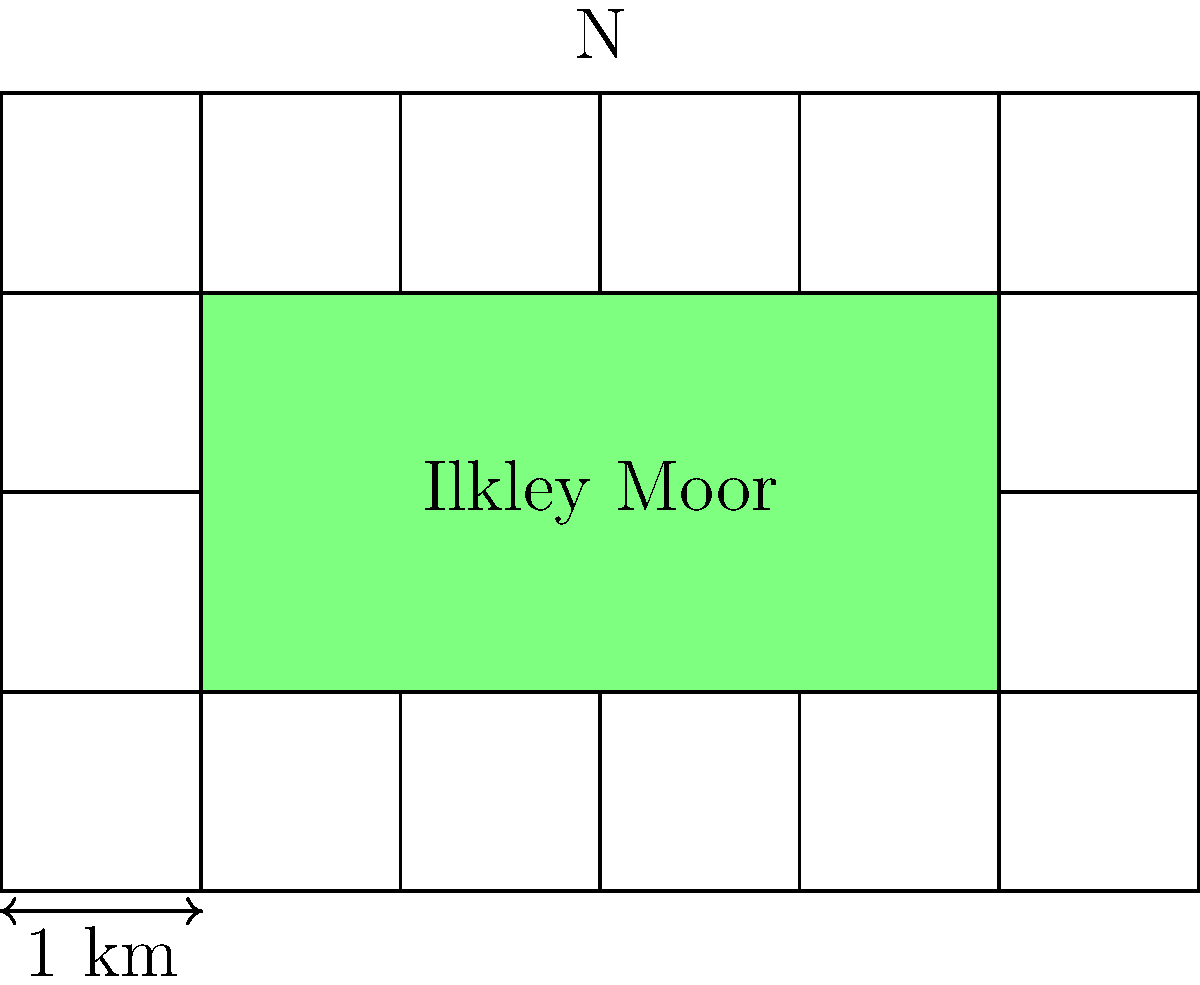Ah, let's take a look at this map of Ilkley Moor, lad. It reminds me of the old Ordnance Survey maps we used to use. Now, the green area represents Ilkley Moor, and each grid square is 1 km by 1 km. Can you calculate the total area of Ilkley Moor in square kilometers? Right then, let's break this down step by step:

1) First, we need to count the number of full squares within the green area:
   There are 4 full squares (2 rows of 2 squares each)

2) Now, we need to account for the partial squares:
   - On the left side, we have 2 half squares, which is equivalent to 1 full square
   - On the right side, we also have 2 half squares, which is another full square

3) Adding these up:
   $4 + 1 + 1 = 6$ square units

4) Remember, each square represents 1 km by 1 km, so each square unit is 1 square kilometer

5) Therefore, the total area is 6 square kilometers

This method of counting squares is just like how we used to estimate areas on our old maps back in the day. It's a practical skill that's served me well over the years, whether for planning hikes or just understanding the lay of the land.
Answer: 6 km² 